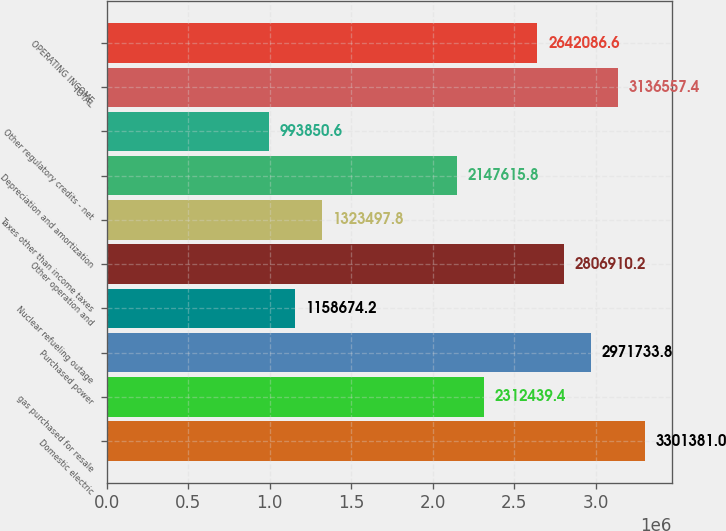<chart> <loc_0><loc_0><loc_500><loc_500><bar_chart><fcel>Domestic electric<fcel>gas purchased for resale<fcel>Purchased power<fcel>Nuclear refueling outage<fcel>Other operation and<fcel>Taxes other than income taxes<fcel>Depreciation and amortization<fcel>Other regulatory credits - net<fcel>TOTAL<fcel>OPERATING INCOME<nl><fcel>3.30138e+06<fcel>2.31244e+06<fcel>2.97173e+06<fcel>1.15867e+06<fcel>2.80691e+06<fcel>1.3235e+06<fcel>2.14762e+06<fcel>993851<fcel>3.13656e+06<fcel>2.64209e+06<nl></chart> 